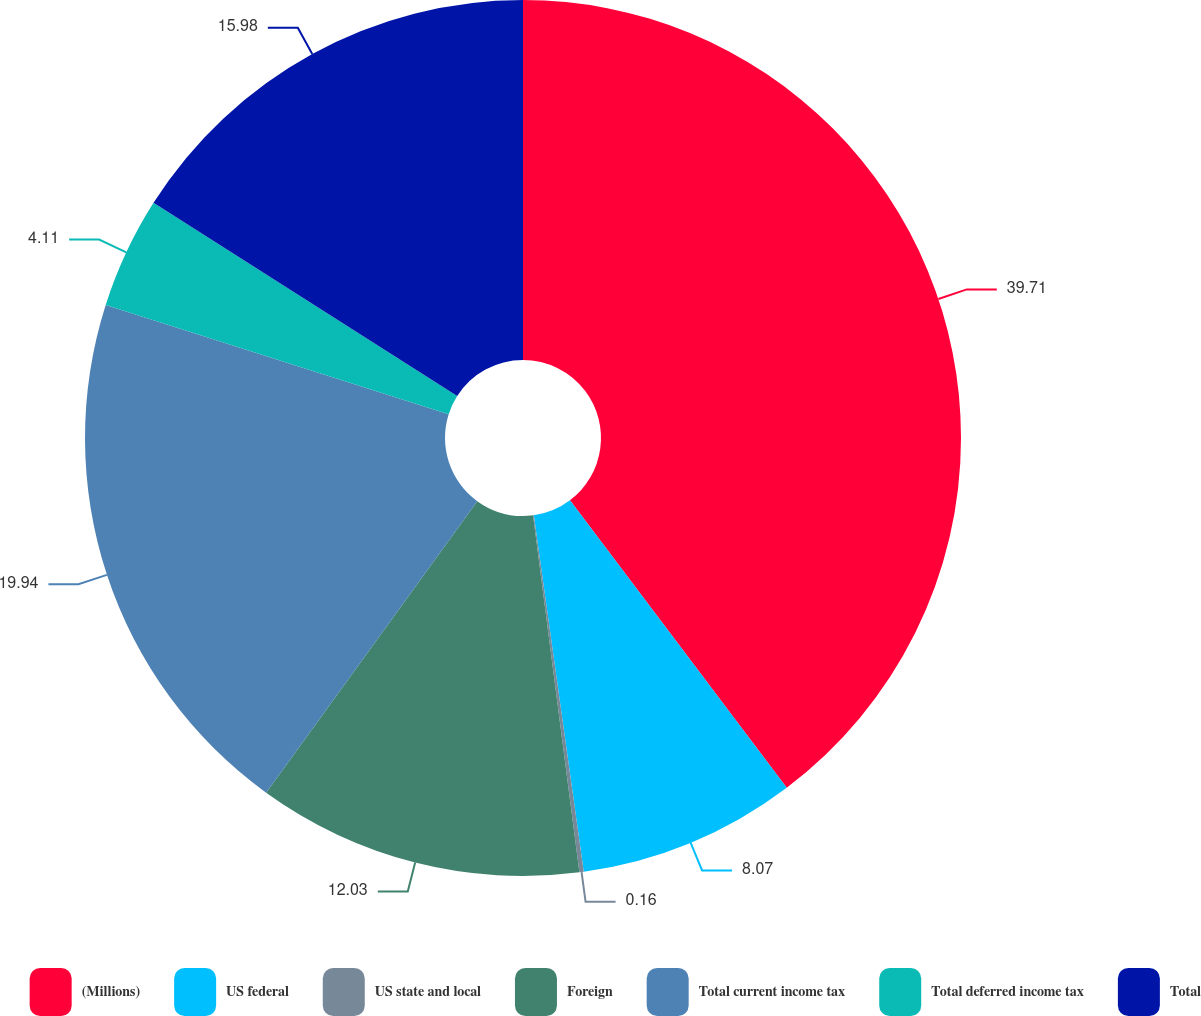Convert chart. <chart><loc_0><loc_0><loc_500><loc_500><pie_chart><fcel>(Millions)<fcel>US federal<fcel>US state and local<fcel>Foreign<fcel>Total current income tax<fcel>Total deferred income tax<fcel>Total<nl><fcel>39.72%<fcel>8.07%<fcel>0.16%<fcel>12.03%<fcel>19.94%<fcel>4.11%<fcel>15.98%<nl></chart> 